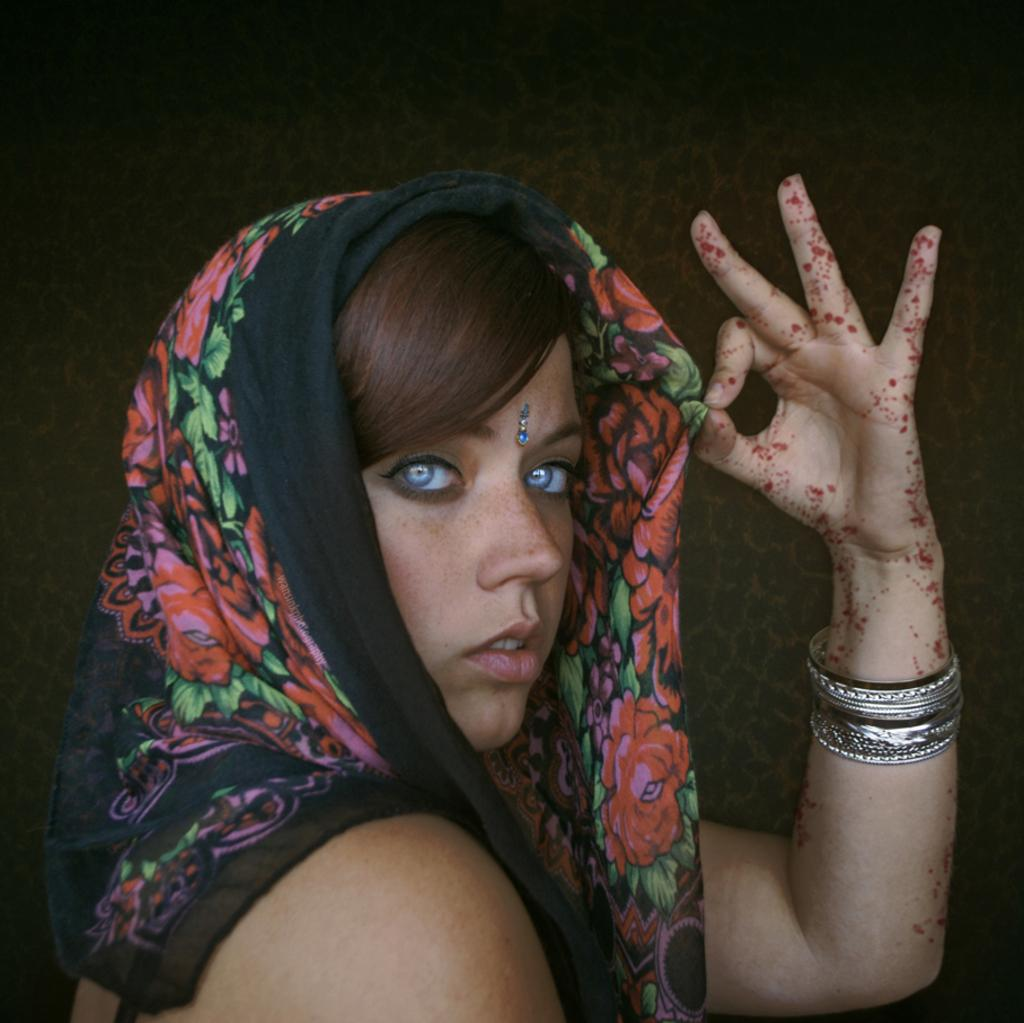Who is the main subject in the image? There is a woman in the image. What is the woman wearing around her neck? The woman is wearing a black and red color scarf. What type of accessory is the woman wearing on her hand? The woman is wearing bangles on her hand. What type of honey is the woman holding in the image? There is no honey present in the image; the woman is wearing a scarf and bangles. 